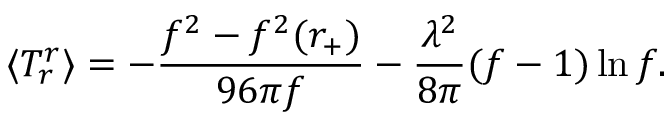Convert formula to latex. <formula><loc_0><loc_0><loc_500><loc_500>\langle T _ { r } ^ { r } \rangle = - { \frac { f ^ { 2 } - f ^ { 2 } ( r _ { + } ) } { 9 6 \pi f } } - { \frac { \lambda ^ { 2 } } { 8 \pi } } ( f - 1 ) \ln f .</formula> 